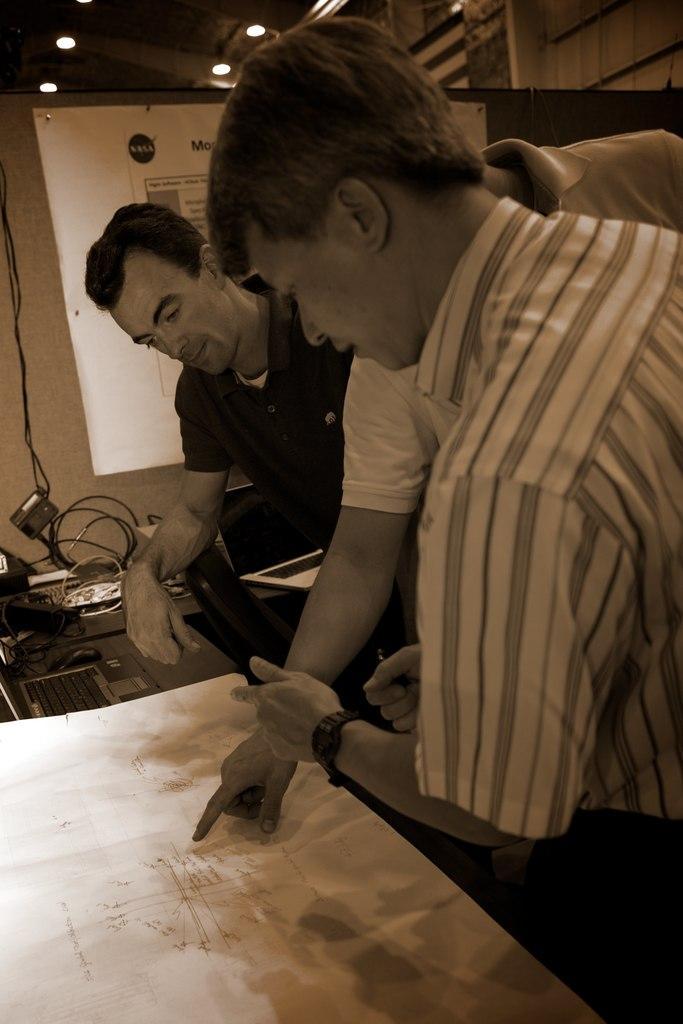How would you summarize this image in a sentence or two? In the picture we can see some people are standing near the desk and one person is showing something in the paper on the desk and in the background, we can see a wall with some white color board and some information on it and to the ceiling we can see some lights. 